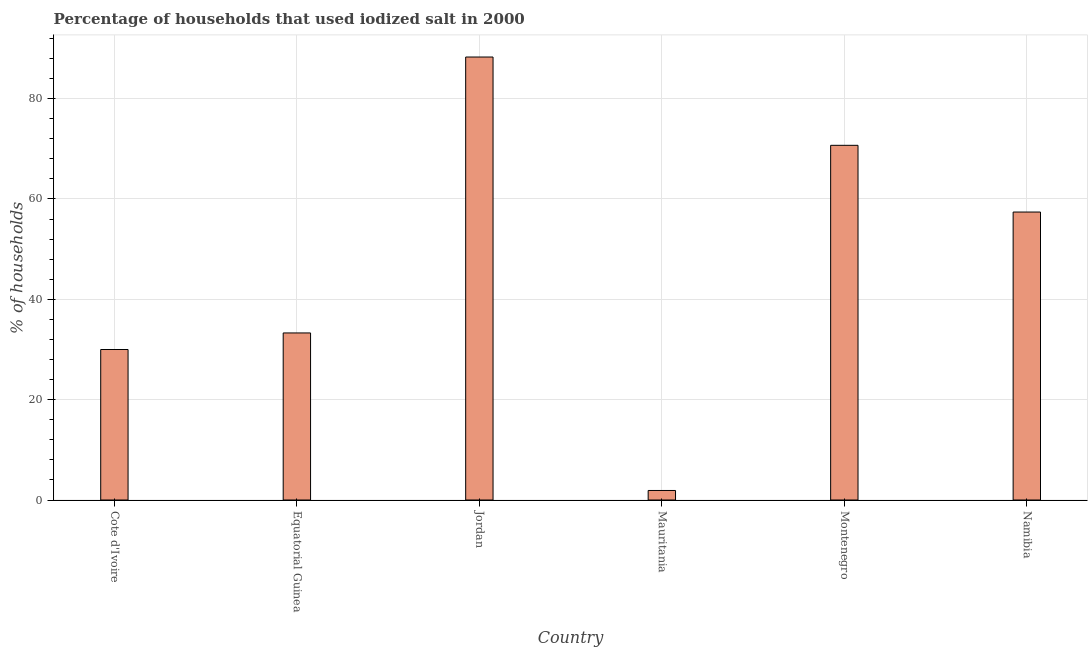Does the graph contain any zero values?
Give a very brief answer. No. Does the graph contain grids?
Keep it short and to the point. Yes. What is the title of the graph?
Your response must be concise. Percentage of households that used iodized salt in 2000. What is the label or title of the X-axis?
Provide a succinct answer. Country. What is the label or title of the Y-axis?
Your answer should be compact. % of households. What is the percentage of households where iodized salt is consumed in Montenegro?
Your answer should be compact. 70.7. Across all countries, what is the maximum percentage of households where iodized salt is consumed?
Make the answer very short. 88.3. In which country was the percentage of households where iodized salt is consumed maximum?
Offer a very short reply. Jordan. In which country was the percentage of households where iodized salt is consumed minimum?
Make the answer very short. Mauritania. What is the sum of the percentage of households where iodized salt is consumed?
Provide a short and direct response. 281.6. What is the difference between the percentage of households where iodized salt is consumed in Equatorial Guinea and Jordan?
Provide a short and direct response. -55. What is the average percentage of households where iodized salt is consumed per country?
Provide a succinct answer. 46.93. What is the median percentage of households where iodized salt is consumed?
Ensure brevity in your answer.  45.35. In how many countries, is the percentage of households where iodized salt is consumed greater than 76 %?
Your answer should be compact. 1. What is the ratio of the percentage of households where iodized salt is consumed in Cote d'Ivoire to that in Jordan?
Your response must be concise. 0.34. Is the percentage of households where iodized salt is consumed in Cote d'Ivoire less than that in Mauritania?
Your answer should be compact. No. What is the difference between the highest and the lowest percentage of households where iodized salt is consumed?
Keep it short and to the point. 86.4. In how many countries, is the percentage of households where iodized salt is consumed greater than the average percentage of households where iodized salt is consumed taken over all countries?
Make the answer very short. 3. How many bars are there?
Your answer should be compact. 6. Are the values on the major ticks of Y-axis written in scientific E-notation?
Give a very brief answer. No. What is the % of households of Equatorial Guinea?
Your answer should be very brief. 33.3. What is the % of households of Jordan?
Ensure brevity in your answer.  88.3. What is the % of households in Montenegro?
Your response must be concise. 70.7. What is the % of households in Namibia?
Provide a succinct answer. 57.4. What is the difference between the % of households in Cote d'Ivoire and Jordan?
Provide a short and direct response. -58.3. What is the difference between the % of households in Cote d'Ivoire and Mauritania?
Your response must be concise. 28.1. What is the difference between the % of households in Cote d'Ivoire and Montenegro?
Your answer should be very brief. -40.7. What is the difference between the % of households in Cote d'Ivoire and Namibia?
Offer a terse response. -27.4. What is the difference between the % of households in Equatorial Guinea and Jordan?
Make the answer very short. -55. What is the difference between the % of households in Equatorial Guinea and Mauritania?
Provide a short and direct response. 31.4. What is the difference between the % of households in Equatorial Guinea and Montenegro?
Offer a terse response. -37.4. What is the difference between the % of households in Equatorial Guinea and Namibia?
Offer a very short reply. -24.1. What is the difference between the % of households in Jordan and Mauritania?
Keep it short and to the point. 86.4. What is the difference between the % of households in Jordan and Montenegro?
Offer a terse response. 17.6. What is the difference between the % of households in Jordan and Namibia?
Provide a succinct answer. 30.9. What is the difference between the % of households in Mauritania and Montenegro?
Your answer should be compact. -68.8. What is the difference between the % of households in Mauritania and Namibia?
Your answer should be compact. -55.5. What is the ratio of the % of households in Cote d'Ivoire to that in Equatorial Guinea?
Offer a very short reply. 0.9. What is the ratio of the % of households in Cote d'Ivoire to that in Jordan?
Ensure brevity in your answer.  0.34. What is the ratio of the % of households in Cote d'Ivoire to that in Mauritania?
Offer a very short reply. 15.79. What is the ratio of the % of households in Cote d'Ivoire to that in Montenegro?
Your answer should be very brief. 0.42. What is the ratio of the % of households in Cote d'Ivoire to that in Namibia?
Provide a short and direct response. 0.52. What is the ratio of the % of households in Equatorial Guinea to that in Jordan?
Your answer should be very brief. 0.38. What is the ratio of the % of households in Equatorial Guinea to that in Mauritania?
Ensure brevity in your answer.  17.53. What is the ratio of the % of households in Equatorial Guinea to that in Montenegro?
Your answer should be very brief. 0.47. What is the ratio of the % of households in Equatorial Guinea to that in Namibia?
Ensure brevity in your answer.  0.58. What is the ratio of the % of households in Jordan to that in Mauritania?
Offer a very short reply. 46.47. What is the ratio of the % of households in Jordan to that in Montenegro?
Keep it short and to the point. 1.25. What is the ratio of the % of households in Jordan to that in Namibia?
Offer a very short reply. 1.54. What is the ratio of the % of households in Mauritania to that in Montenegro?
Make the answer very short. 0.03. What is the ratio of the % of households in Mauritania to that in Namibia?
Your answer should be compact. 0.03. What is the ratio of the % of households in Montenegro to that in Namibia?
Give a very brief answer. 1.23. 